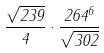<formula> <loc_0><loc_0><loc_500><loc_500>\frac { \sqrt { 2 3 9 } } { 4 } \cdot \frac { 2 6 4 ^ { 6 } } { \sqrt { 3 0 2 } }</formula> 